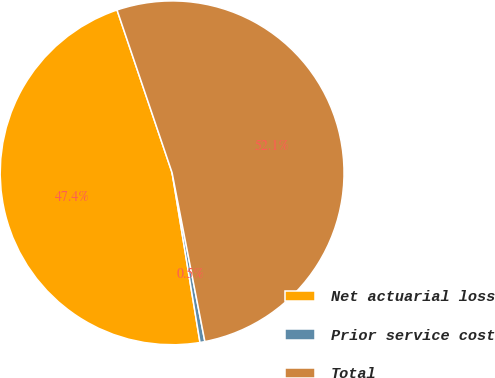<chart> <loc_0><loc_0><loc_500><loc_500><pie_chart><fcel>Net actuarial loss<fcel>Prior service cost<fcel>Total<nl><fcel>47.4%<fcel>0.46%<fcel>52.14%<nl></chart> 